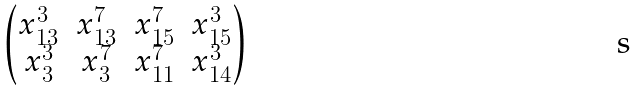<formula> <loc_0><loc_0><loc_500><loc_500>\begin{pmatrix} x _ { 1 3 } ^ { 3 } & x _ { 1 3 } ^ { 7 } & x _ { 1 5 } ^ { 7 } & x _ { 1 5 } ^ { 3 } \\ x _ { 3 } ^ { 3 } & x _ { 3 } ^ { 7 } & x _ { 1 1 } ^ { 7 } & x _ { 1 4 } ^ { 3 } \end{pmatrix}</formula> 